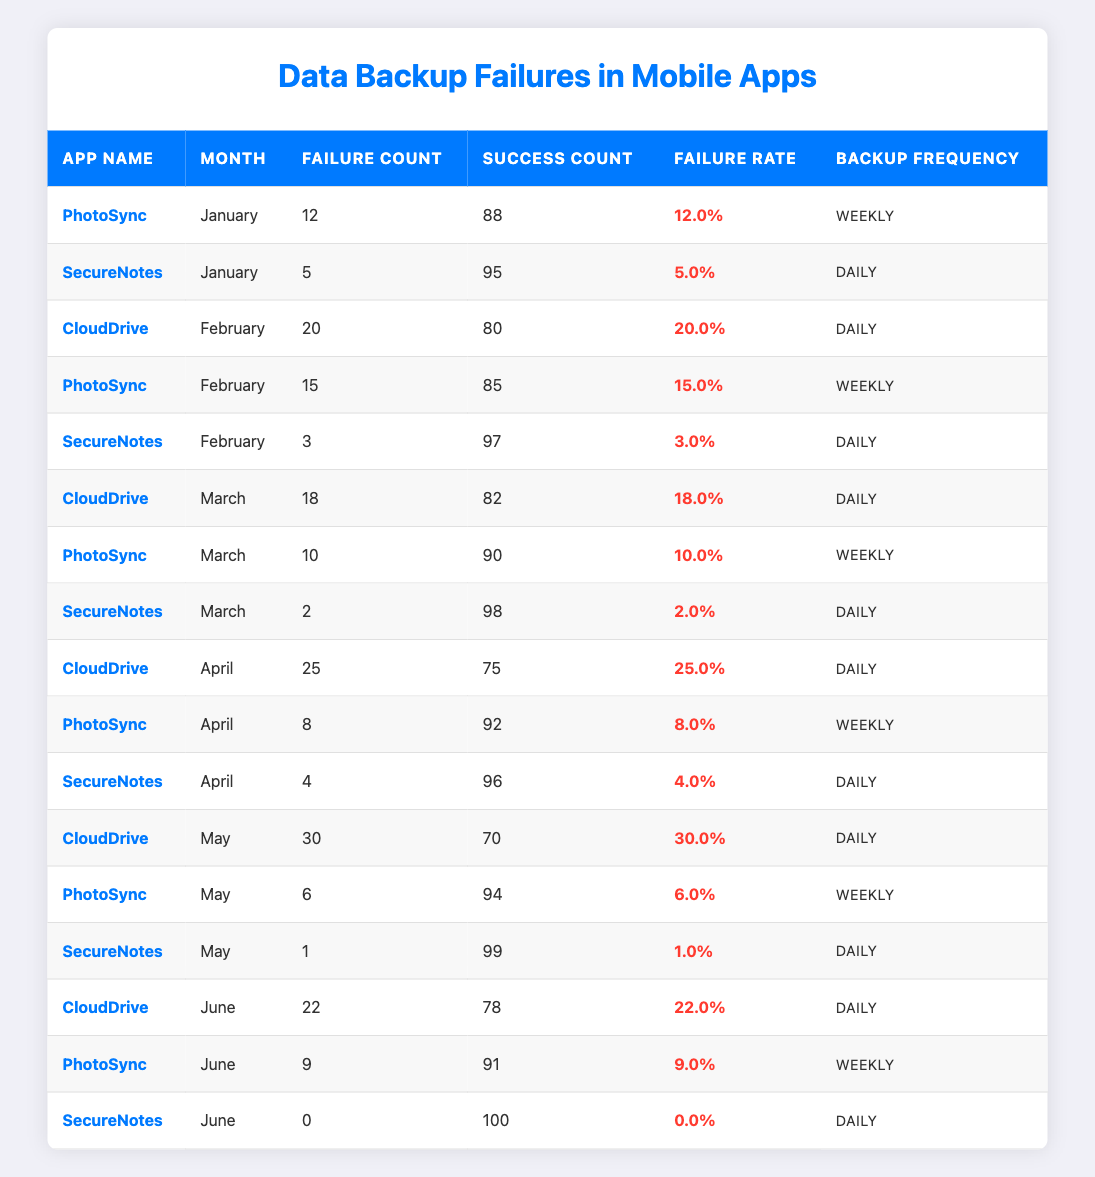What is the failure count for SecureNotes in March? The table shows that SecureNotes has a failure count of 2 in March.
Answer: 2 Which app had the highest failure rate in April? In April, CloudDrive had the highest failure rate at 25.0%.
Answer: CloudDrive What is the total success count for PhotoSync over the six months? Summing up the success counts for PhotoSync: 88 (Jan) + 85 (Feb) + 90 (Mar) + 92 (Apr) + 94 (May) + 91 (Jun) = 540.
Answer: 540 Did SecureNotes experience any backup failures in June? According to the table, SecureNotes had 0 failures in June.
Answer: Yes What was the average failure rate for CloudDrive across the six months? The failure rates for CloudDrive are 20.0% (Feb), 18.0% (Mar), 25.0% (Apr), 30.0% (May), and 22.0% (Jun). Summing them gives 115.0% and dividing by 5 results in an average failure rate of 23.0%.
Answer: 23.0% Which app had the least number of failures in May? In May, SecureNotes had the least number of failures with just 1 failure compared to PhotoSync and CloudDrive.
Answer: SecureNotes What is the month with the highest total failure count across all apps? The failures are: January (12 + 5), February (20 + 15 + 3), March (18 + 10 + 2), April (25 + 8 + 4), May (30 + 6 + 1), June (22 + 9 + 0). The counts for May sum to 37, which is the highest.
Answer: May Was the backup frequency for SecureNotes consistent throughout the given months? SecureNotes maintained a daily backup frequency throughout all months, indicating consistency.
Answer: Yes 